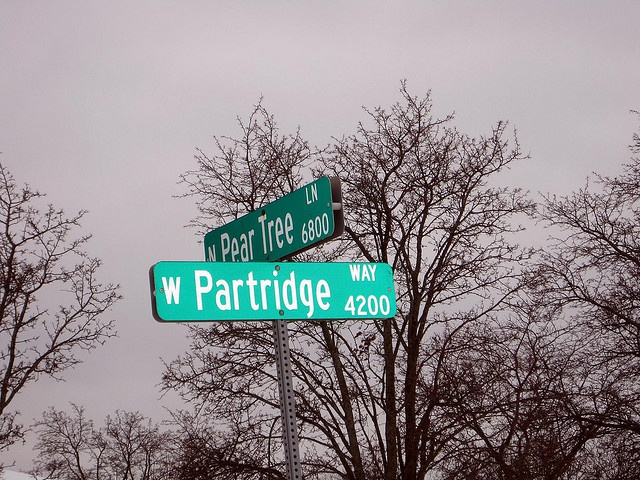Describe the objects in this image and their specific colors. I can see various objects in this image with different colors. 